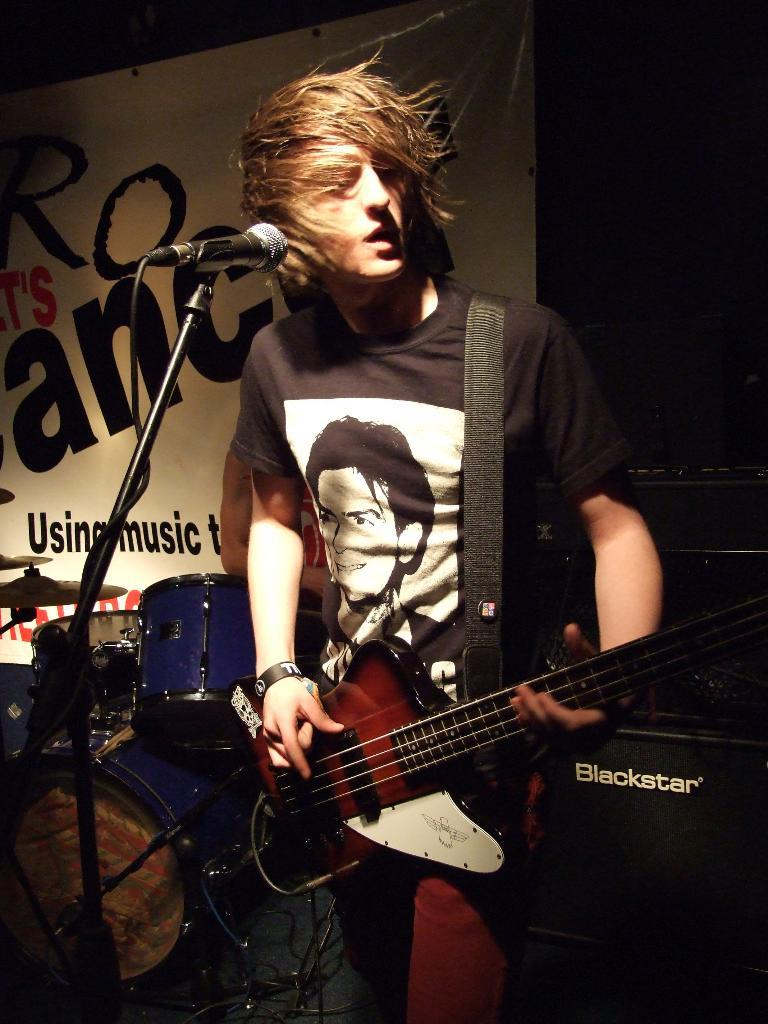What is the boy in the image holding? The boy is holding a guitar and a microphone. What can be seen in the background of the image? There is a drum set, a poster, and an unspecified object in the background of the image. What type of jeans is the boy wearing in the image? The provided facts do not mention the boy's jeans, so we cannot determine the type of jeans he is wearing. 